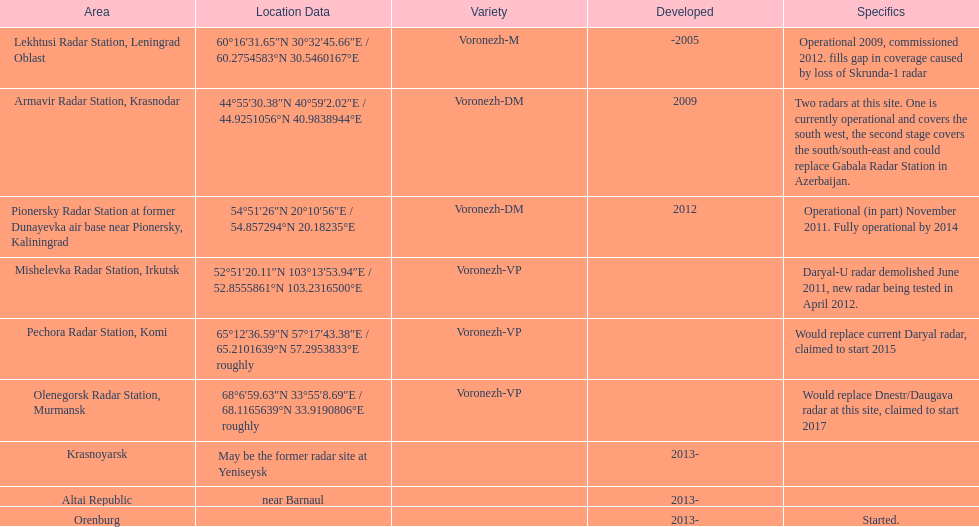What is the only radar that will start in 2015? Pechora Radar Station, Komi. 